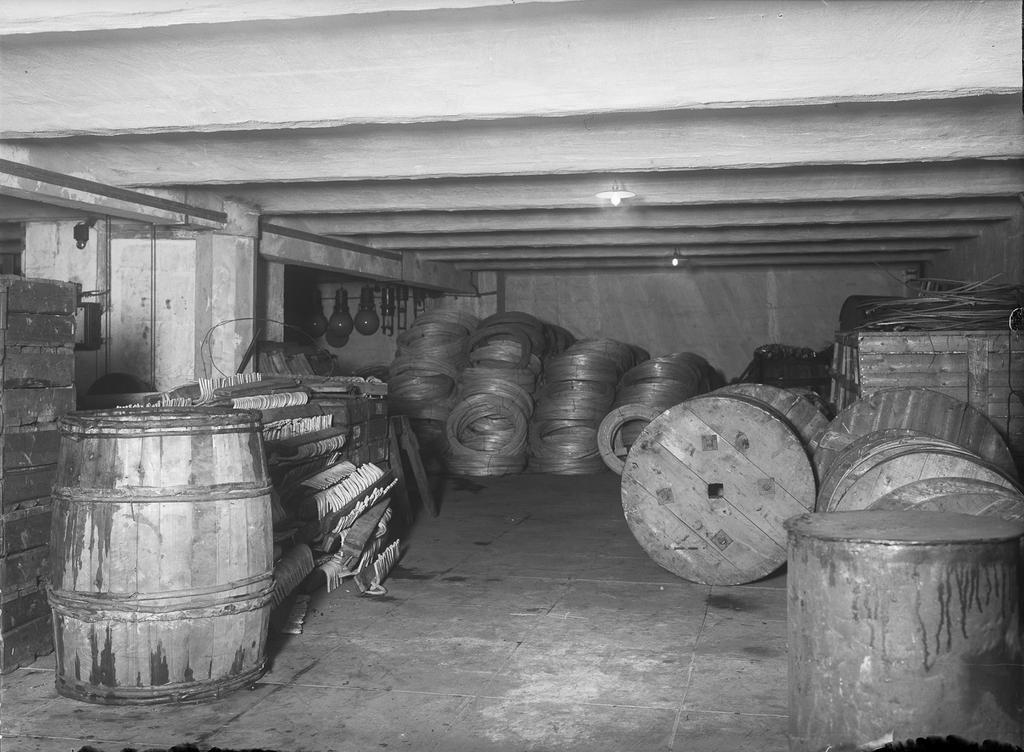What type of objects can be seen in the image? There are barrels and wooden bars in the image. Are there any damaged objects in the image? Yes, there are wounded wires in the image. What type of lighting is present in the image? Electric lights are visible in the image. How does the butter contribute to the overall appearance of the image? There is no butter present in the image, so it cannot contribute to the overall appearance. 